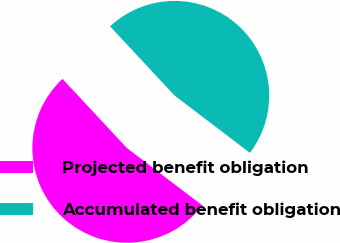<chart> <loc_0><loc_0><loc_500><loc_500><pie_chart><fcel>Projected benefit obligation<fcel>Accumulated benefit obligation<nl><fcel>52.71%<fcel>47.29%<nl></chart> 